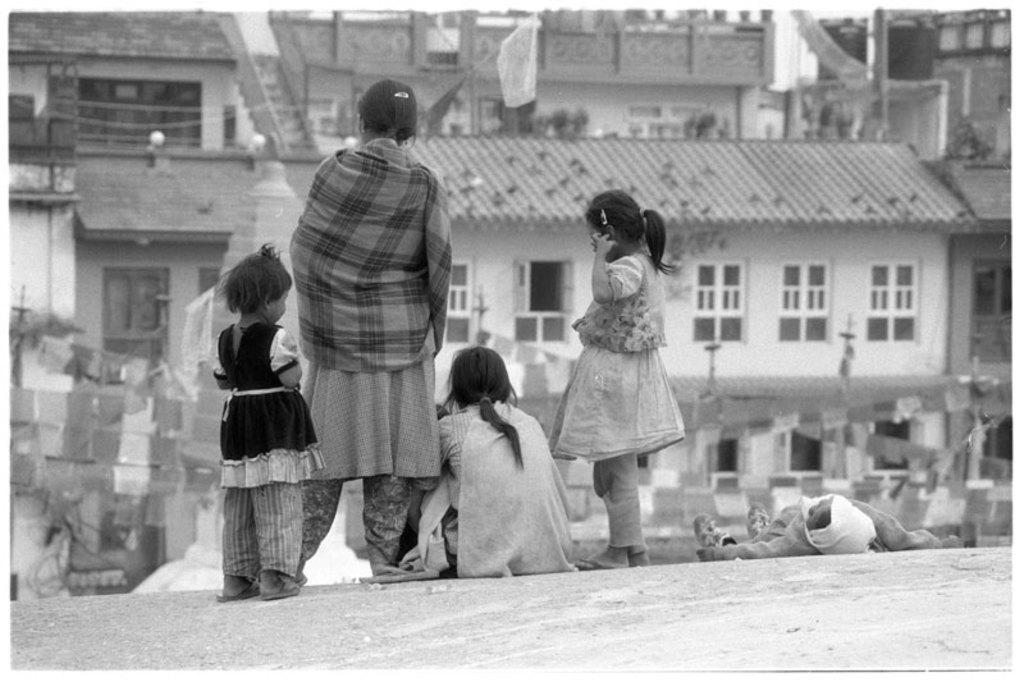Describe this image in one or two sentences. In this black and white picture a woman is sitting on the floor. A person is lying on the floor. Two girls and a woman are standing. Background there are few buildings. 